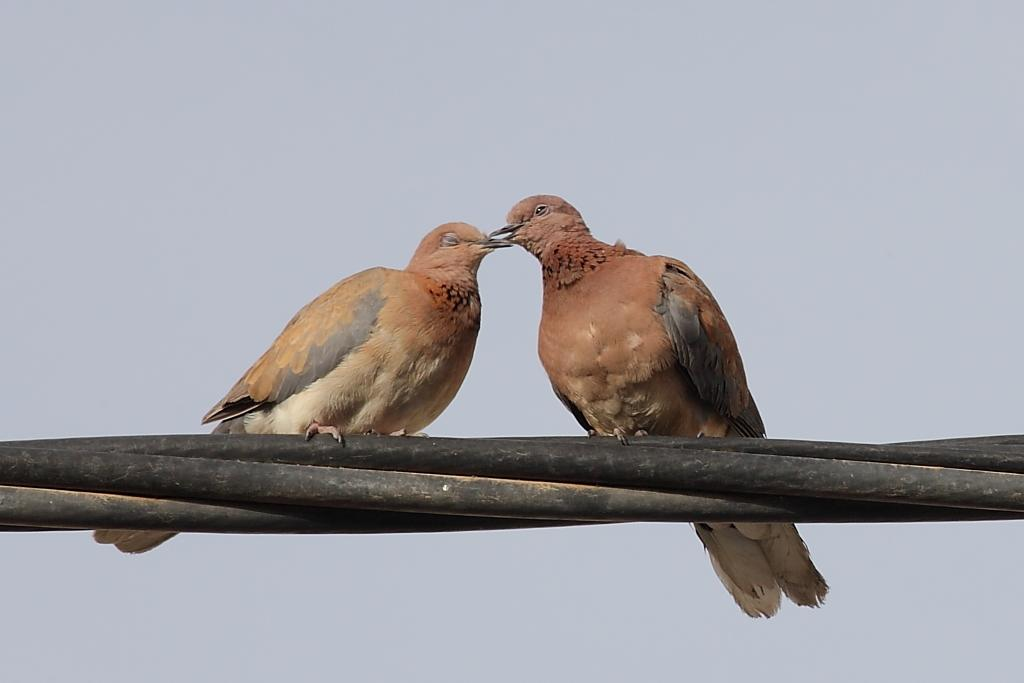What type of animals can be seen in the image? There are birds in the image. Where are the birds located? The birds are standing on wires. What is the condition of the sky in the image? The sky is cloudy in the image. What type of tent can be seen in the image? There is no tent present in the image. How does the son react to the birds in the image? There is no son present in the image, so it is impossible to determine their reaction. 